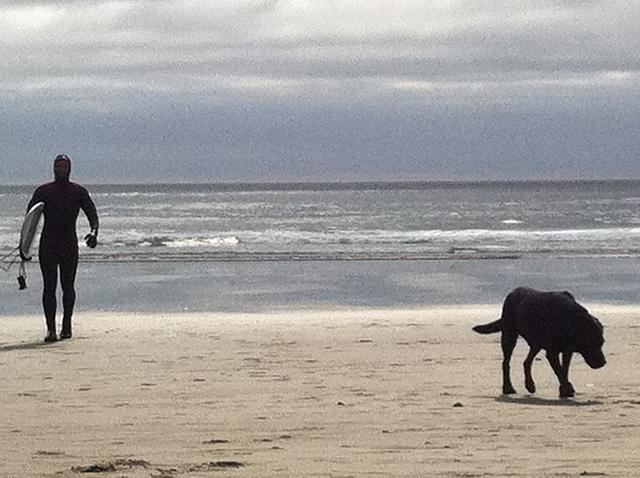Who owns this dog? Please explain your reasoning. surfer. The surfer is the only other person in the picture and is likely the owner. 